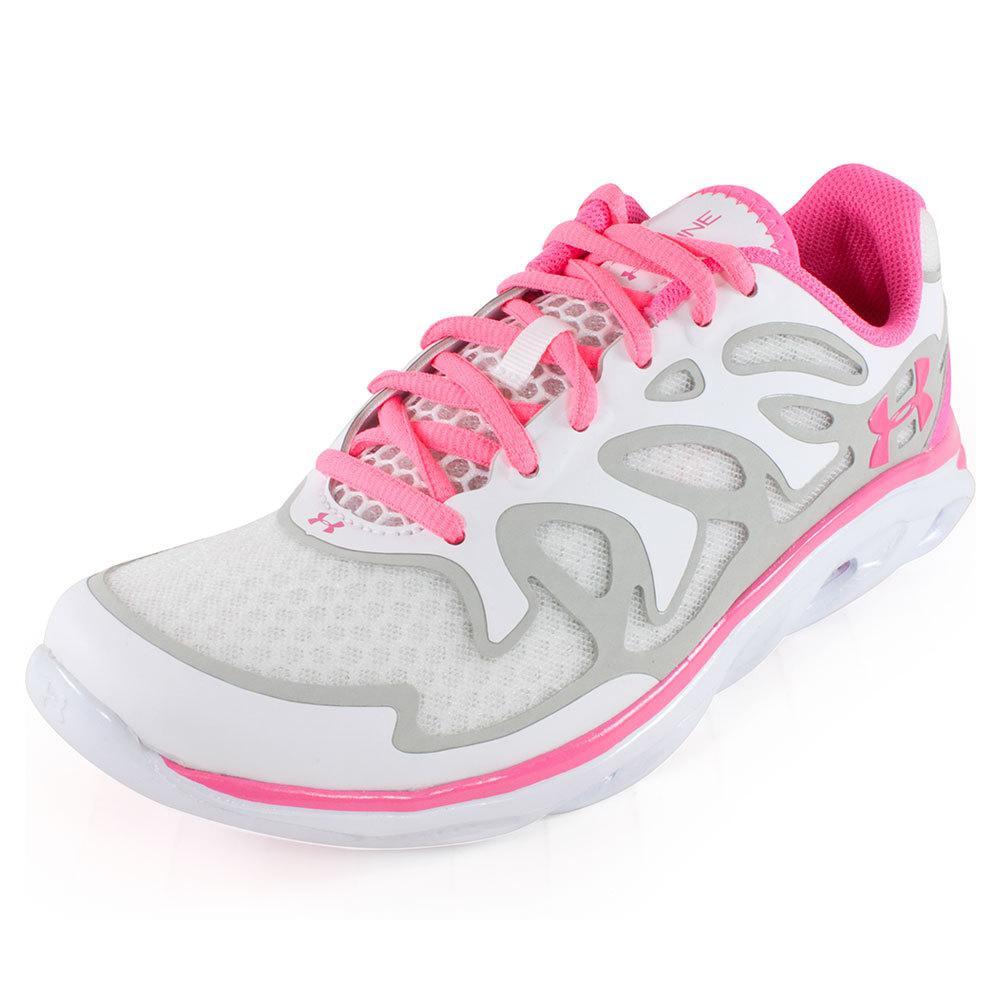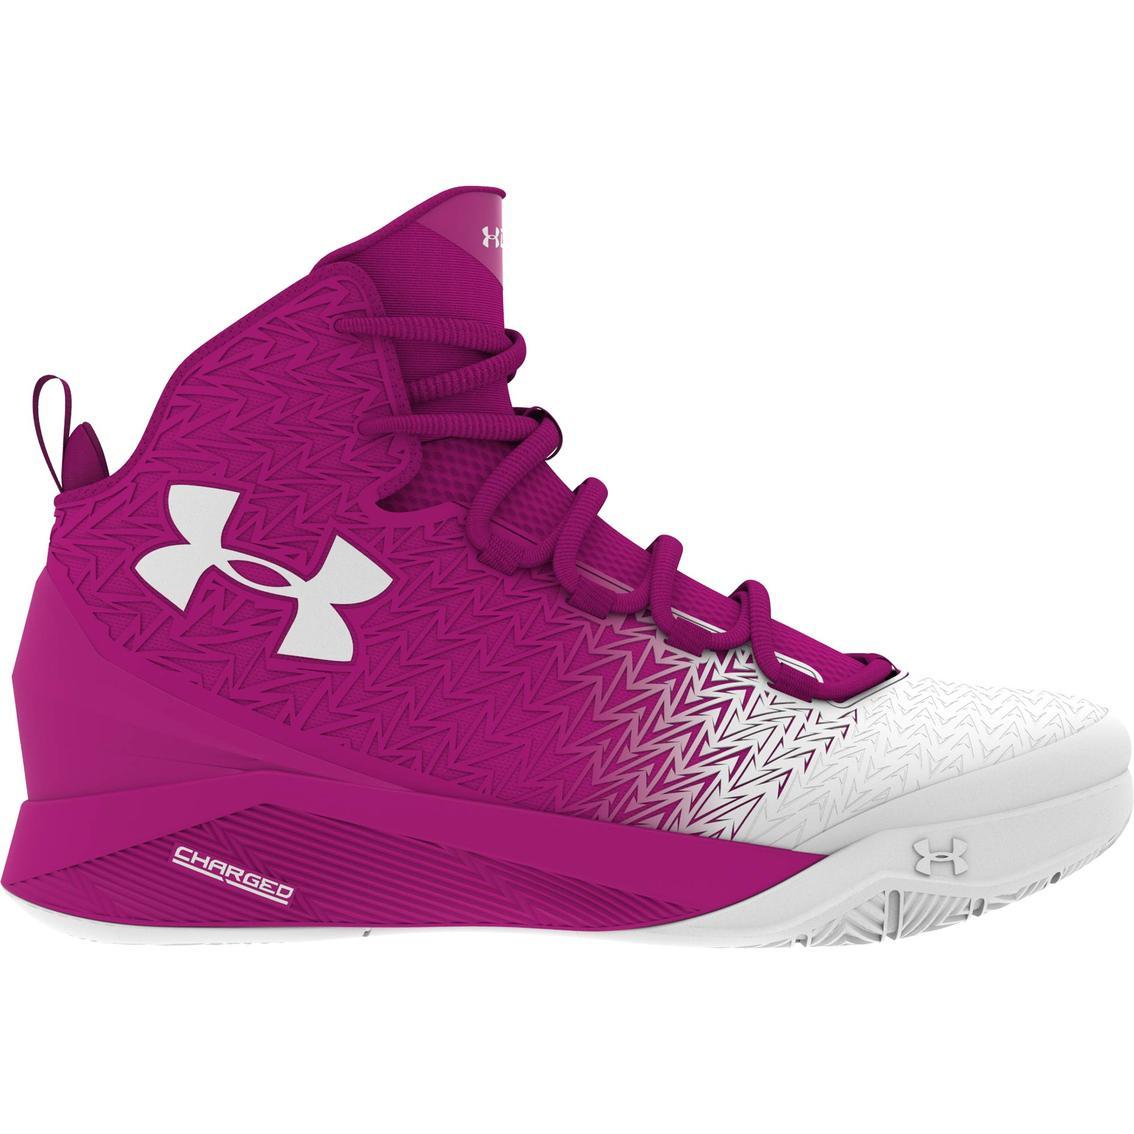The first image is the image on the left, the second image is the image on the right. Assess this claim about the two images: "There are three total shoes in the pair.". Correct or not? Answer yes or no. No. 